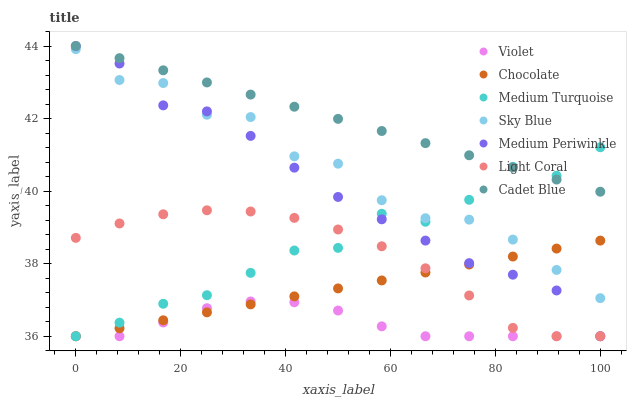Does Violet have the minimum area under the curve?
Answer yes or no. Yes. Does Cadet Blue have the maximum area under the curve?
Answer yes or no. Yes. Does Medium Periwinkle have the minimum area under the curve?
Answer yes or no. No. Does Medium Periwinkle have the maximum area under the curve?
Answer yes or no. No. Is Cadet Blue the smoothest?
Answer yes or no. Yes. Is Sky Blue the roughest?
Answer yes or no. Yes. Is Medium Periwinkle the smoothest?
Answer yes or no. No. Is Medium Periwinkle the roughest?
Answer yes or no. No. Does Medium Periwinkle have the lowest value?
Answer yes or no. Yes. Does Sky Blue have the lowest value?
Answer yes or no. No. Does Medium Periwinkle have the highest value?
Answer yes or no. Yes. Does Chocolate have the highest value?
Answer yes or no. No. Is Chocolate less than Cadet Blue?
Answer yes or no. Yes. Is Cadet Blue greater than Chocolate?
Answer yes or no. Yes. Does Medium Turquoise intersect Cadet Blue?
Answer yes or no. Yes. Is Medium Turquoise less than Cadet Blue?
Answer yes or no. No. Is Medium Turquoise greater than Cadet Blue?
Answer yes or no. No. Does Chocolate intersect Cadet Blue?
Answer yes or no. No. 